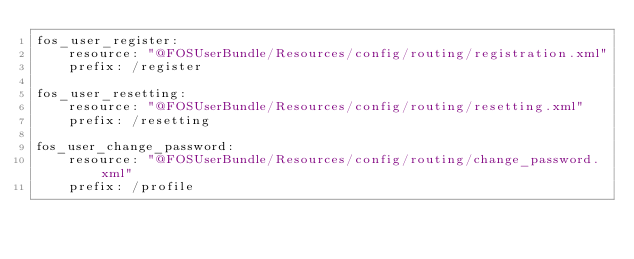<code> <loc_0><loc_0><loc_500><loc_500><_YAML_>fos_user_register:
    resource: "@FOSUserBundle/Resources/config/routing/registration.xml"
    prefix: /register

fos_user_resetting:
    resource: "@FOSUserBundle/Resources/config/routing/resetting.xml"
    prefix: /resetting

fos_user_change_password:
    resource: "@FOSUserBundle/Resources/config/routing/change_password.xml"
    prefix: /profile</code> 